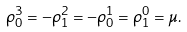Convert formula to latex. <formula><loc_0><loc_0><loc_500><loc_500>\rho ^ { 3 } _ { 0 } = - \rho ^ { 2 } _ { 1 } = - \rho ^ { 1 } _ { 0 } = \rho ^ { 0 } _ { 1 } = \mu .</formula> 